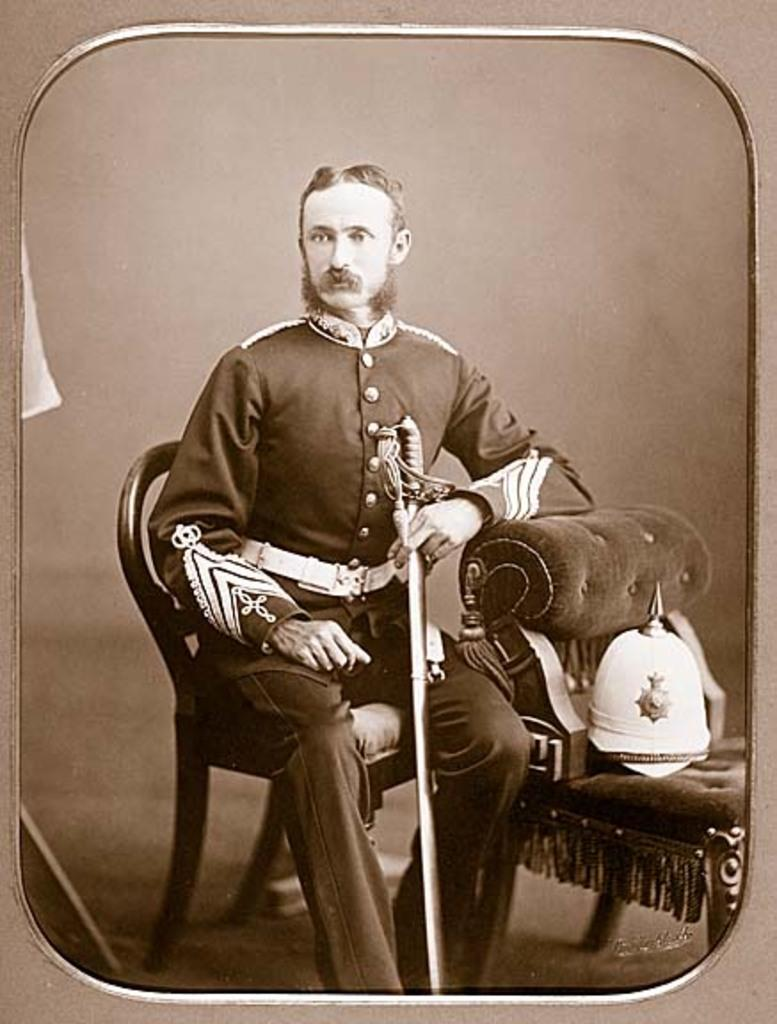What is the person in the image doing? The person is sitting in a chair in the image. What object is the person holding? The person is holding a sword. What other object related to the sword can be seen in the image? There is a helmet on a chair in front of the person. What type of stove can be seen in the image? There is no stove present in the image. What thoughts might the person be having while holding the sword? We cannot determine the person's thoughts from the image alone. 